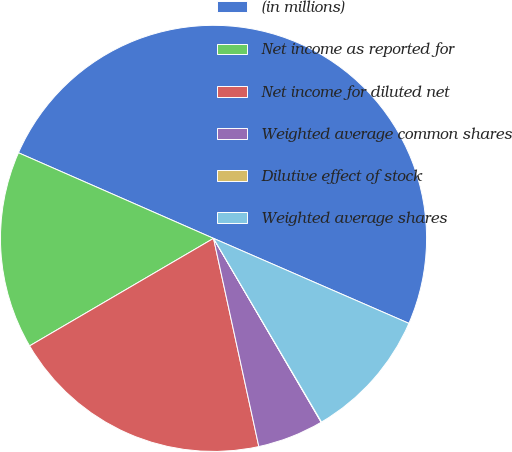Convert chart. <chart><loc_0><loc_0><loc_500><loc_500><pie_chart><fcel>(in millions)<fcel>Net income as reported for<fcel>Net income for diluted net<fcel>Weighted average common shares<fcel>Dilutive effect of stock<fcel>Weighted average shares<nl><fcel>49.95%<fcel>15.0%<fcel>19.99%<fcel>5.02%<fcel>0.03%<fcel>10.01%<nl></chart> 